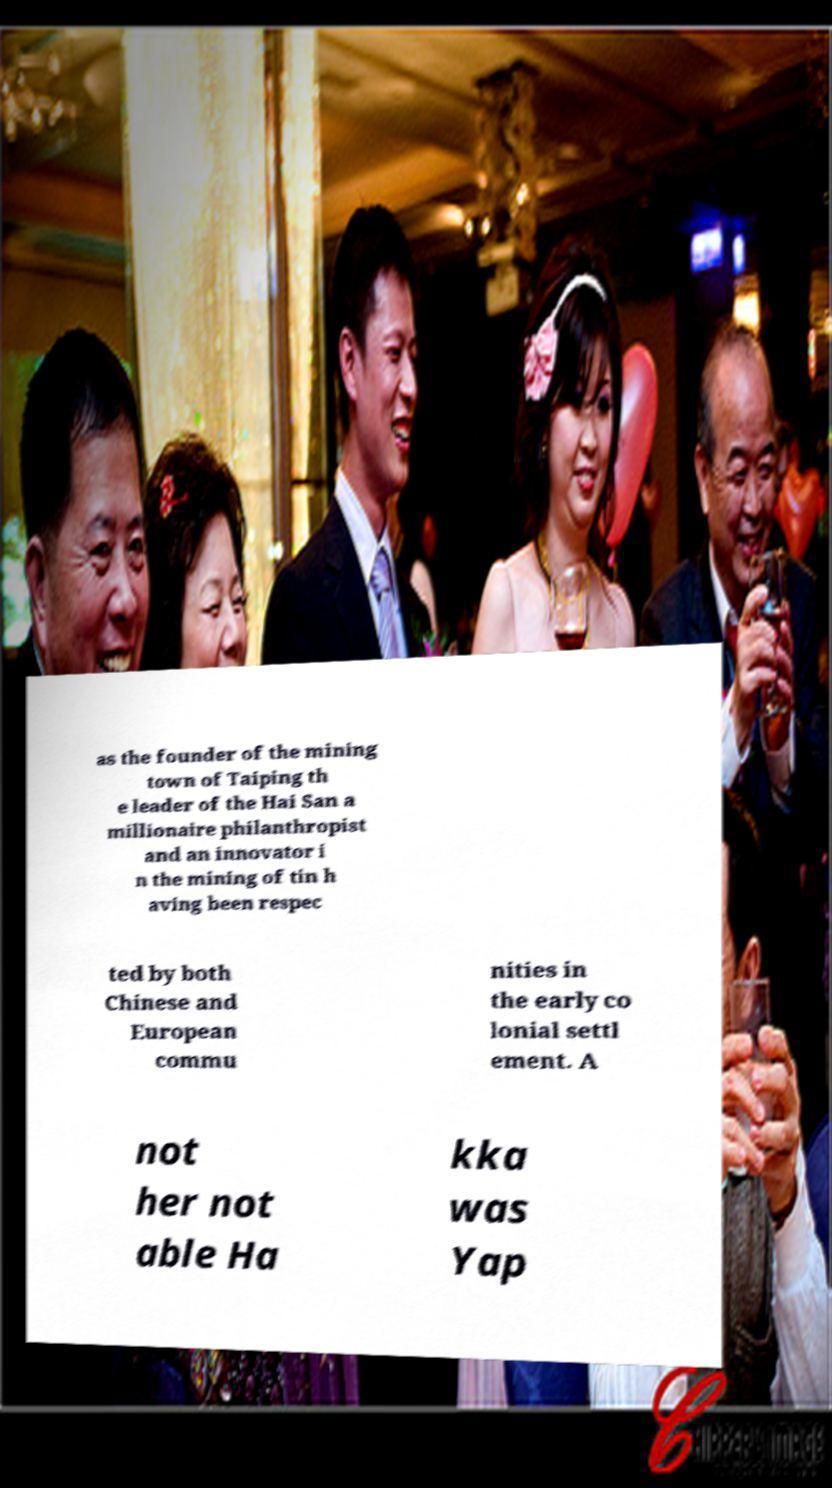There's text embedded in this image that I need extracted. Can you transcribe it verbatim? as the founder of the mining town of Taiping th e leader of the Hai San a millionaire philanthropist and an innovator i n the mining of tin h aving been respec ted by both Chinese and European commu nities in the early co lonial settl ement. A not her not able Ha kka was Yap 